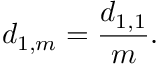<formula> <loc_0><loc_0><loc_500><loc_500>d _ { 1 , m } = \frac { d _ { 1 , 1 } } { m } .</formula> 